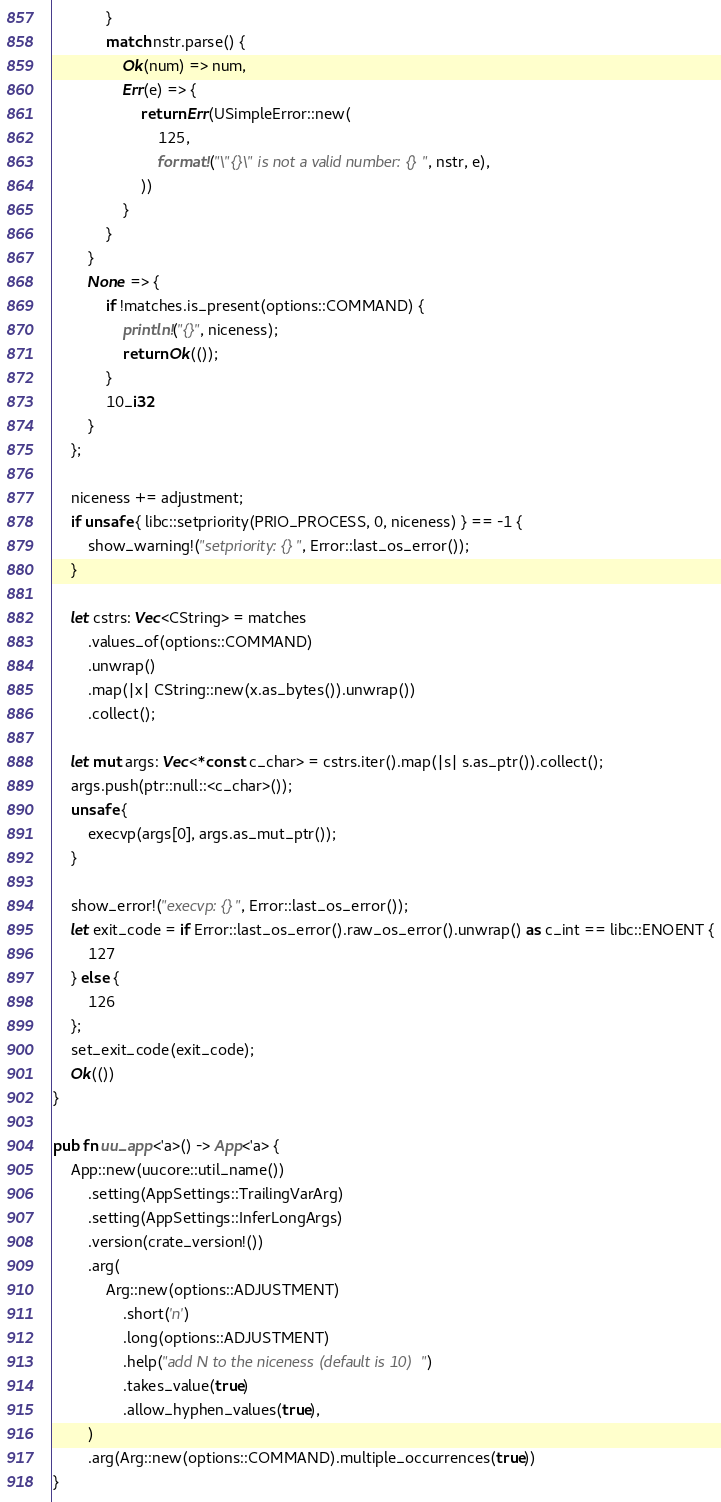<code> <loc_0><loc_0><loc_500><loc_500><_Rust_>            }
            match nstr.parse() {
                Ok(num) => num,
                Err(e) => {
                    return Err(USimpleError::new(
                        125,
                        format!("\"{}\" is not a valid number: {}", nstr, e),
                    ))
                }
            }
        }
        None => {
            if !matches.is_present(options::COMMAND) {
                println!("{}", niceness);
                return Ok(());
            }
            10_i32
        }
    };

    niceness += adjustment;
    if unsafe { libc::setpriority(PRIO_PROCESS, 0, niceness) } == -1 {
        show_warning!("setpriority: {}", Error::last_os_error());
    }

    let cstrs: Vec<CString> = matches
        .values_of(options::COMMAND)
        .unwrap()
        .map(|x| CString::new(x.as_bytes()).unwrap())
        .collect();

    let mut args: Vec<*const c_char> = cstrs.iter().map(|s| s.as_ptr()).collect();
    args.push(ptr::null::<c_char>());
    unsafe {
        execvp(args[0], args.as_mut_ptr());
    }

    show_error!("execvp: {}", Error::last_os_error());
    let exit_code = if Error::last_os_error().raw_os_error().unwrap() as c_int == libc::ENOENT {
        127
    } else {
        126
    };
    set_exit_code(exit_code);
    Ok(())
}

pub fn uu_app<'a>() -> App<'a> {
    App::new(uucore::util_name())
        .setting(AppSettings::TrailingVarArg)
        .setting(AppSettings::InferLongArgs)
        .version(crate_version!())
        .arg(
            Arg::new(options::ADJUSTMENT)
                .short('n')
                .long(options::ADJUSTMENT)
                .help("add N to the niceness (default is 10)")
                .takes_value(true)
                .allow_hyphen_values(true),
        )
        .arg(Arg::new(options::COMMAND).multiple_occurrences(true))
}
</code> 